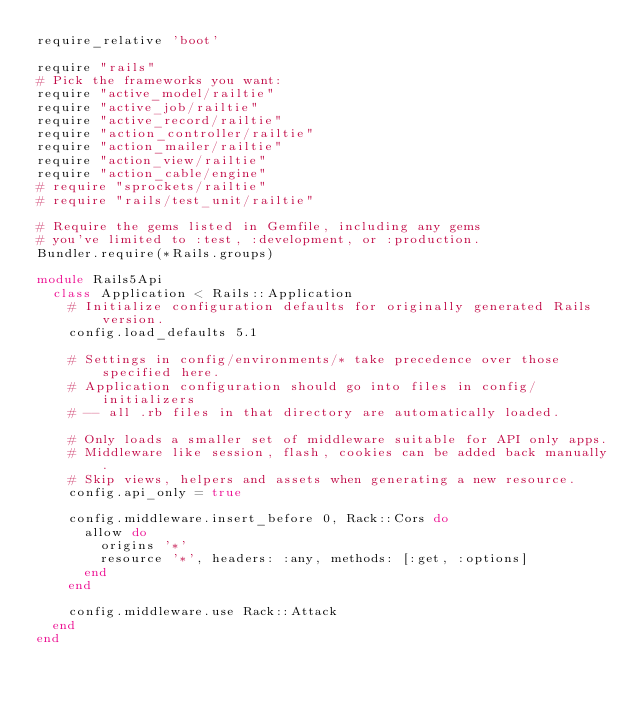<code> <loc_0><loc_0><loc_500><loc_500><_Ruby_>require_relative 'boot'

require "rails"
# Pick the frameworks you want:
require "active_model/railtie"
require "active_job/railtie"
require "active_record/railtie"
require "action_controller/railtie"
require "action_mailer/railtie"
require "action_view/railtie"
require "action_cable/engine"
# require "sprockets/railtie"
# require "rails/test_unit/railtie"

# Require the gems listed in Gemfile, including any gems
# you've limited to :test, :development, or :production.
Bundler.require(*Rails.groups)

module Rails5Api
  class Application < Rails::Application
    # Initialize configuration defaults for originally generated Rails version.
    config.load_defaults 5.1

    # Settings in config/environments/* take precedence over those specified here.
    # Application configuration should go into files in config/initializers
    # -- all .rb files in that directory are automatically loaded.

    # Only loads a smaller set of middleware suitable for API only apps.
    # Middleware like session, flash, cookies can be added back manually.
    # Skip views, helpers and assets when generating a new resource.
    config.api_only = true

    config.middleware.insert_before 0, Rack::Cors do
      allow do
        origins '*'
        resource '*', headers: :any, methods: [:get, :options]
      end
    end

    config.middleware.use Rack::Attack
  end
end
</code> 